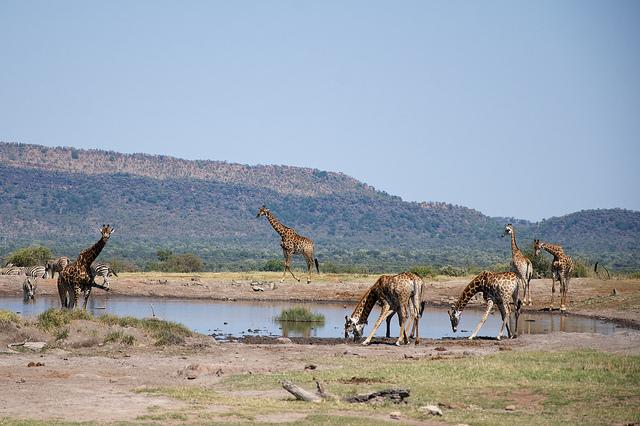How many of the giraffes are taking a drink in the water? two 